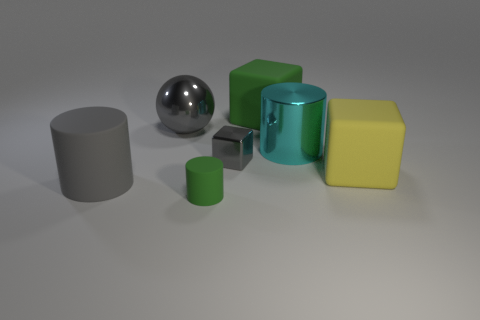Add 2 large rubber cylinders. How many objects exist? 9 Subtract all spheres. How many objects are left? 6 Add 2 large blocks. How many large blocks exist? 4 Subtract 0 cyan balls. How many objects are left? 7 Subtract all large yellow metallic cubes. Subtract all gray cylinders. How many objects are left? 6 Add 5 big gray metal things. How many big gray metal things are left? 6 